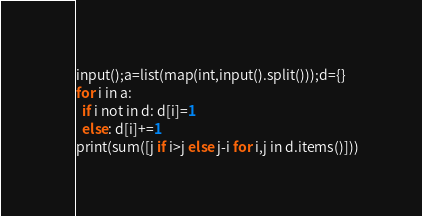<code> <loc_0><loc_0><loc_500><loc_500><_Python_>input();a=list(map(int,input().split()));d={}
for i in a:
  if i not in d: d[i]=1
  else: d[i]+=1
print(sum([j if i>j else j-i for i,j in d.items()]))</code> 